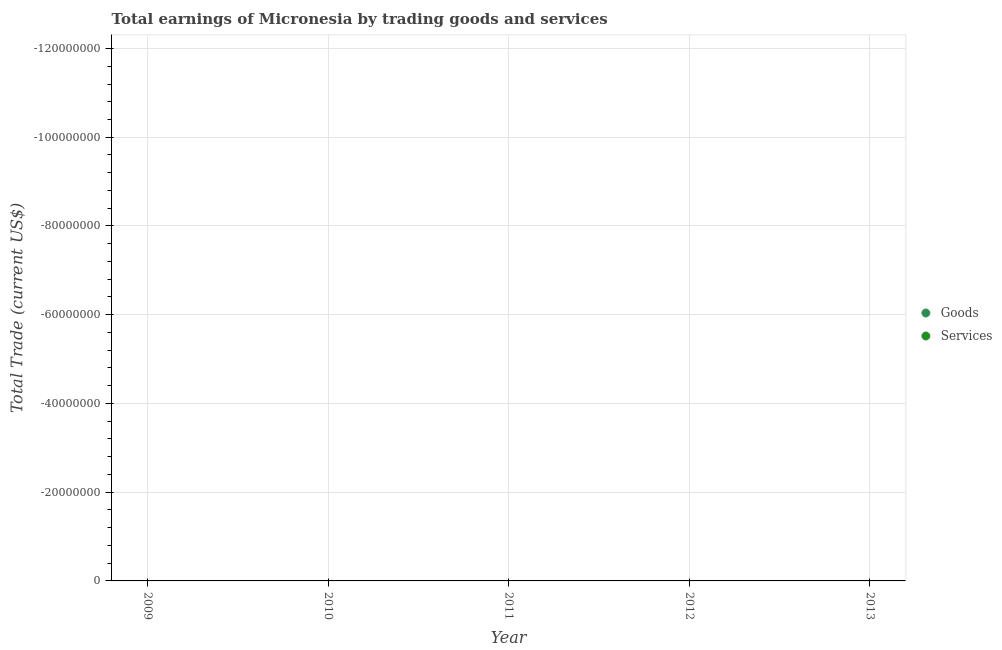How many different coloured dotlines are there?
Keep it short and to the point. 0. What is the total amount earned by trading goods in the graph?
Provide a succinct answer. 0. What is the average amount earned by trading services per year?
Give a very brief answer. 0. In how many years, is the amount earned by trading goods greater than the average amount earned by trading goods taken over all years?
Provide a short and direct response. 0. Does the amount earned by trading services monotonically increase over the years?
Your answer should be very brief. No. Is the amount earned by trading services strictly greater than the amount earned by trading goods over the years?
Make the answer very short. No. What is the difference between two consecutive major ticks on the Y-axis?
Provide a short and direct response. 2.00e+07. Does the graph contain any zero values?
Offer a terse response. Yes. Does the graph contain grids?
Keep it short and to the point. Yes. Where does the legend appear in the graph?
Offer a terse response. Center right. How are the legend labels stacked?
Your answer should be very brief. Vertical. What is the title of the graph?
Your response must be concise. Total earnings of Micronesia by trading goods and services. Does "Electricity" appear as one of the legend labels in the graph?
Your response must be concise. No. What is the label or title of the Y-axis?
Offer a very short reply. Total Trade (current US$). What is the Total Trade (current US$) in Goods in 2009?
Your answer should be very brief. 0. What is the Total Trade (current US$) in Goods in 2010?
Your answer should be compact. 0. What is the Total Trade (current US$) of Services in 2010?
Your answer should be compact. 0. What is the Total Trade (current US$) in Goods in 2011?
Offer a terse response. 0. What is the Total Trade (current US$) of Services in 2011?
Keep it short and to the point. 0. What is the Total Trade (current US$) in Goods in 2012?
Offer a very short reply. 0. What is the Total Trade (current US$) of Goods in 2013?
Your answer should be compact. 0. What is the Total Trade (current US$) in Services in 2013?
Ensure brevity in your answer.  0. What is the total Total Trade (current US$) of Goods in the graph?
Your answer should be compact. 0. What is the average Total Trade (current US$) in Services per year?
Give a very brief answer. 0. 